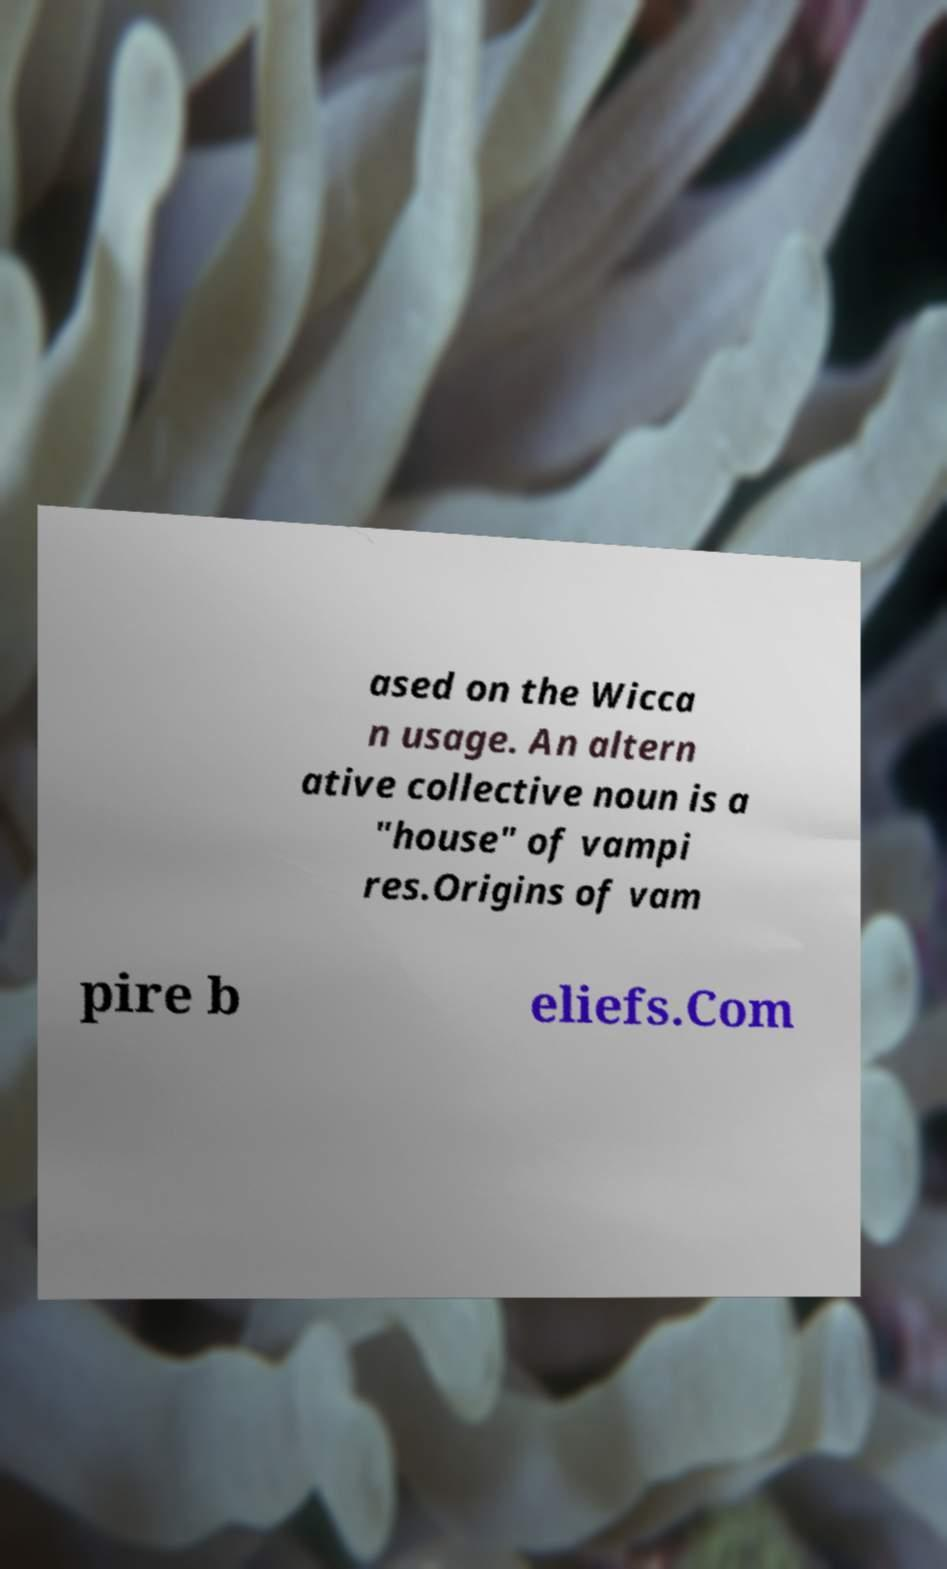Can you read and provide the text displayed in the image?This photo seems to have some interesting text. Can you extract and type it out for me? ased on the Wicca n usage. An altern ative collective noun is a "house" of vampi res.Origins of vam pire b eliefs.Com 